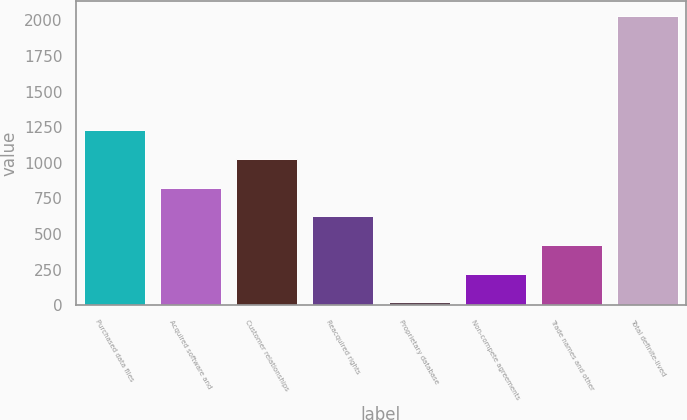Convert chart to OTSL. <chart><loc_0><loc_0><loc_500><loc_500><bar_chart><fcel>Purchased data files<fcel>Acquired software and<fcel>Customer relationships<fcel>Reacquired rights<fcel>Proprietary database<fcel>Non-compete agreements<fcel>Trade names and other<fcel>Total definite-lived<nl><fcel>1228.16<fcel>825.94<fcel>1027.05<fcel>624.83<fcel>21.5<fcel>222.61<fcel>423.72<fcel>2032.6<nl></chart> 